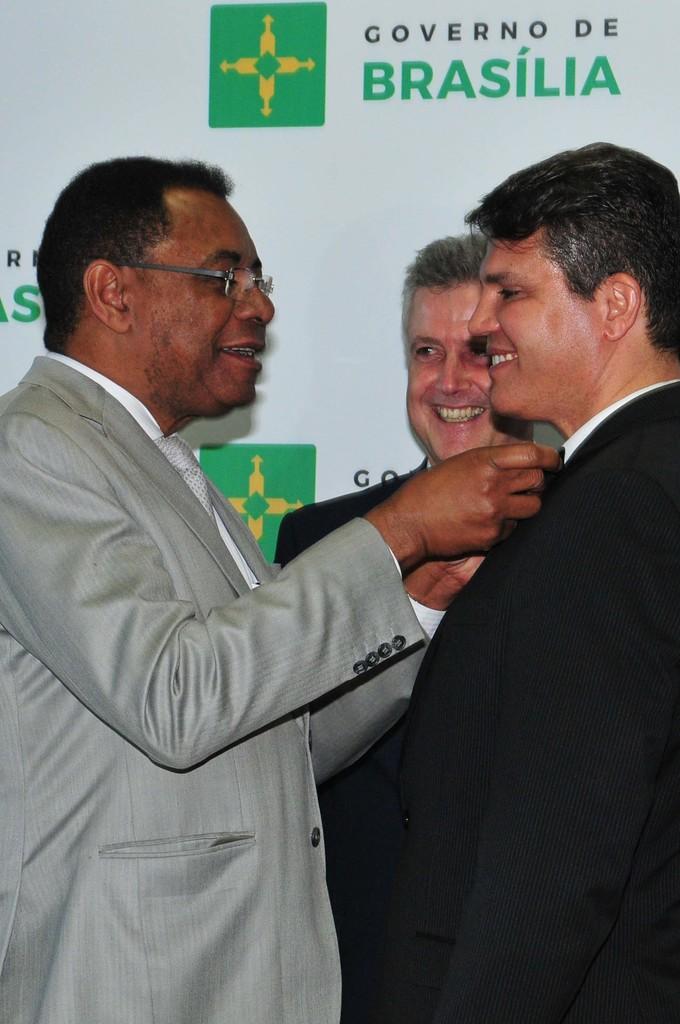Can you describe this image briefly? In the image in the center we can see a few people were standing and they were smiling,which we can see on their faces. In the background there is a banner. 